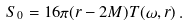<formula> <loc_0><loc_0><loc_500><loc_500>S _ { 0 } = 1 6 \pi ( r - 2 M ) T ( \omega , r ) \, .</formula> 